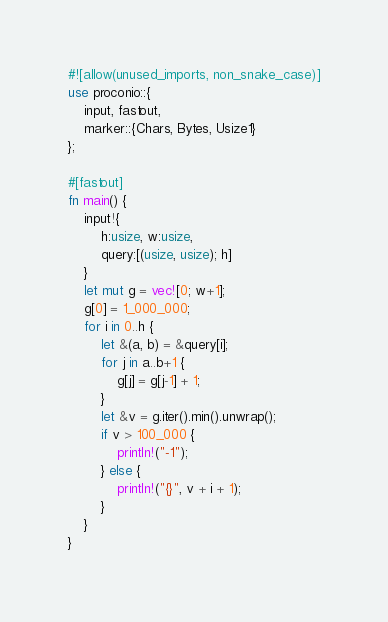Convert code to text. <code><loc_0><loc_0><loc_500><loc_500><_Rust_>#![allow(unused_imports, non_snake_case)]
use proconio::{
    input, fastout,
    marker::{Chars, Bytes, Usize1}
};

#[fastout]
fn main() {
    input!{
        h:usize, w:usize,
        query:[(usize, usize); h]
    }
    let mut g = vec![0; w+1];
    g[0] = 1_000_000;
    for i in 0..h {
        let &(a, b) = &query[i];
        for j in a..b+1 {
            g[j] = g[j-1] + 1;
        }
        let &v = g.iter().min().unwrap();
        if v > 100_000 {
            println!("-1");
        } else {
            println!("{}", v + i + 1);
        }
    }
}
</code> 